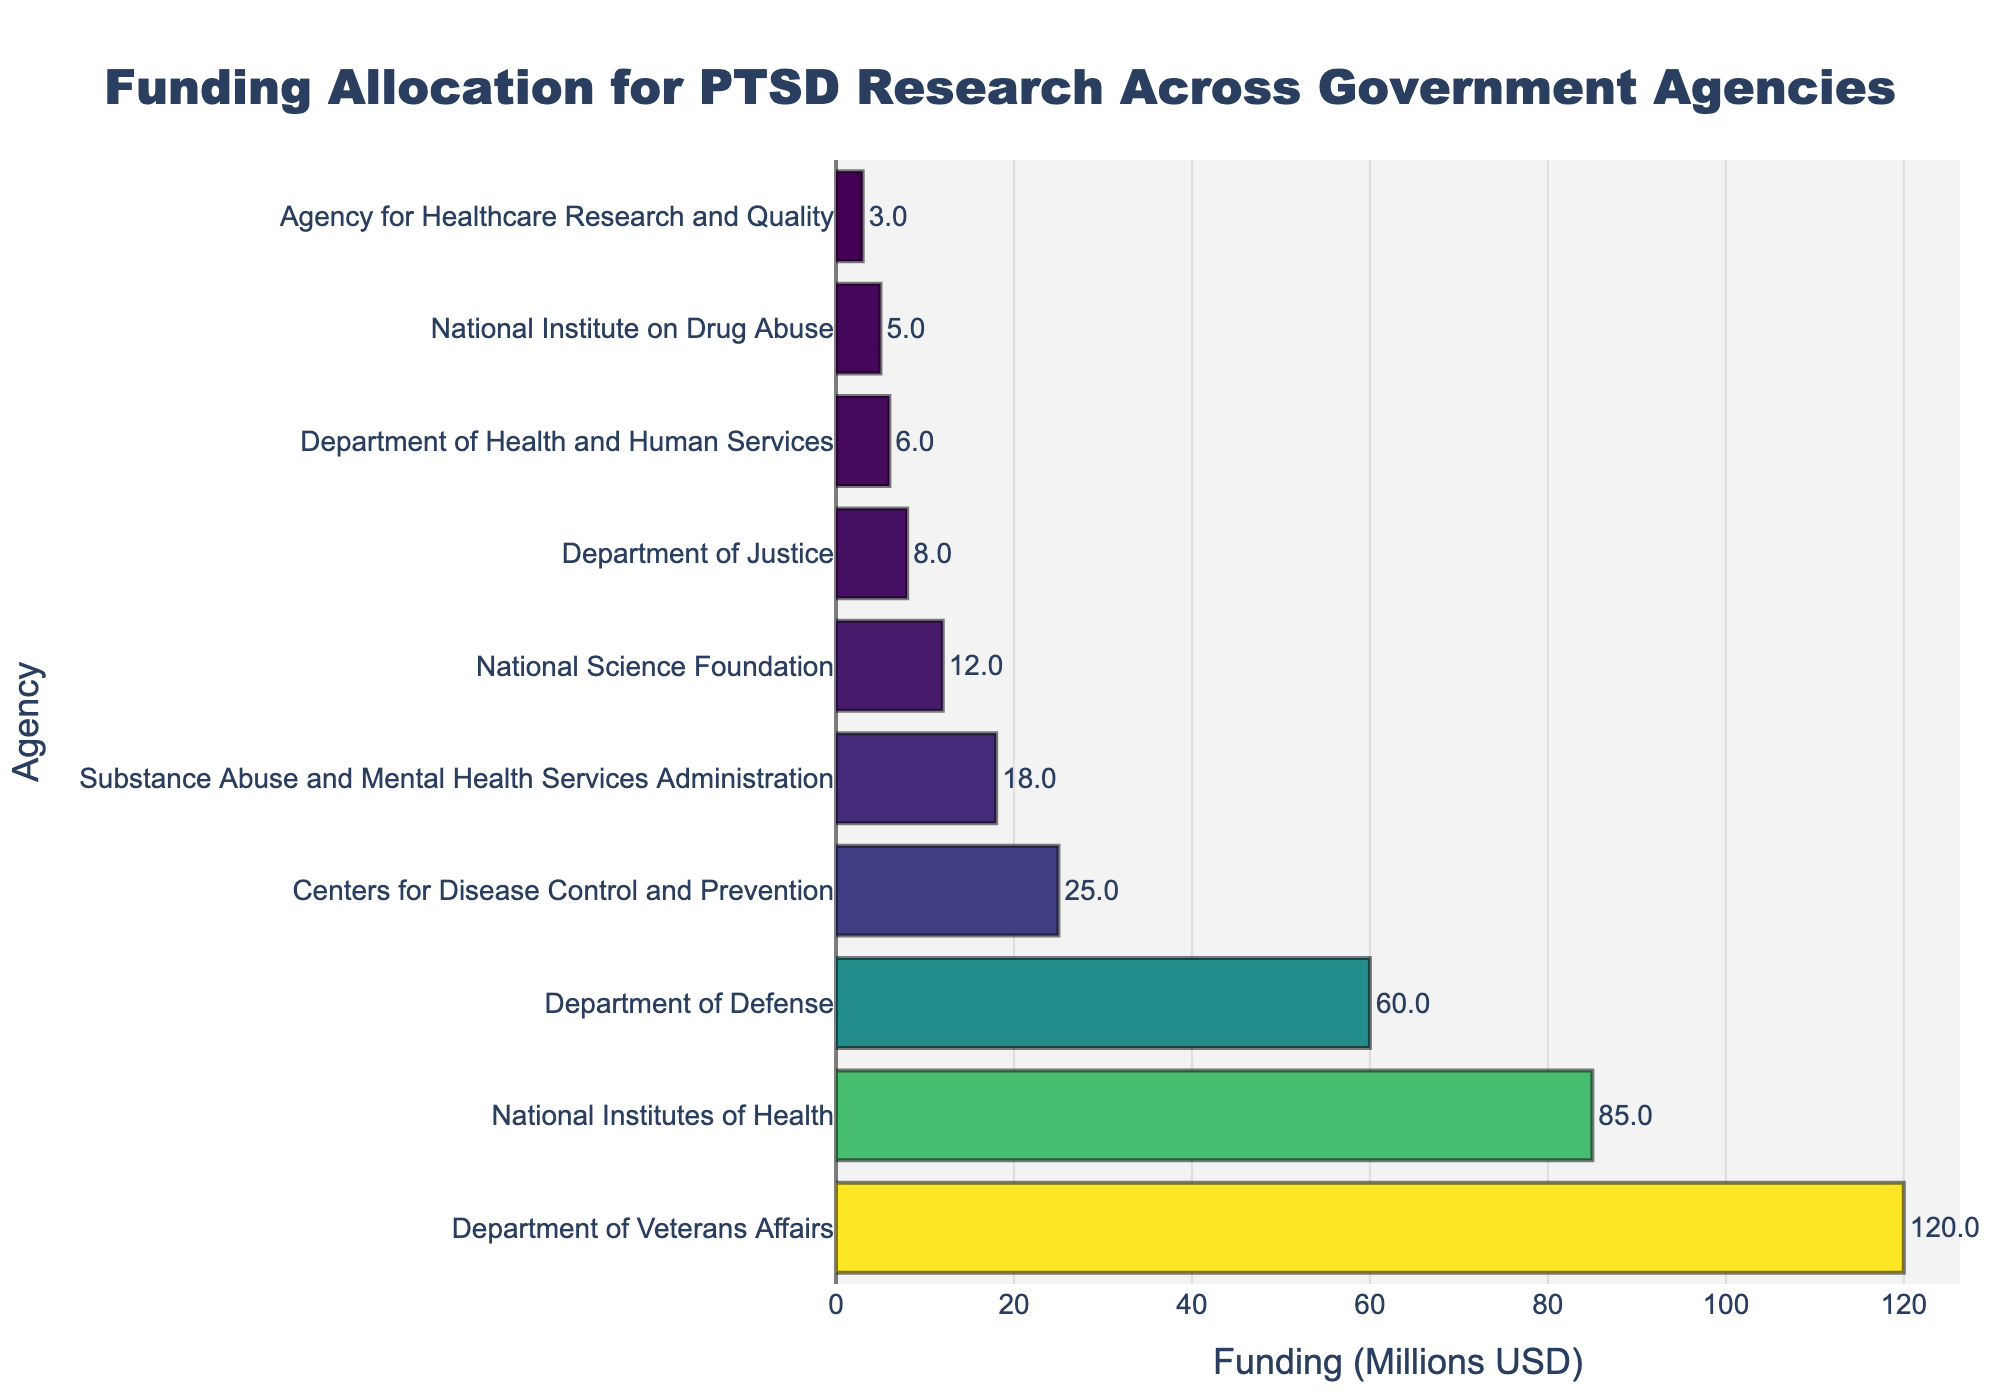How much more funding does the Department of Veterans Affairs receive for PTSD research compared to the Department of Defense? The Department of Veterans Affairs receives 120 million USD, while the Department of Defense receives 60 million USD. The difference is 120 - 60 = 60 million USD.
Answer: 60 million USD What is the total funding allocated for PTSD research by the top three agencies? The top three agencies are the Department of Veterans Affairs (120 million USD), the National Institutes of Health (85 million USD), and the Department of Defense (60 million USD). The total funding is 120 + 85 + 60 = 265 million USD.
Answer: 265 million USD Which agency allocates the least funding for PTSD research? By examining the bar lengths, the Agency for Healthcare Research and Quality allocates the least funding, which is 3 million USD.
Answer: Agency for Healthcare Research and Quality How does the funding allocated by the Centers for Disease Control and Prevention compare to that of the National Science Foundation? The Centers for Disease Control and Prevention allocates 25 million USD, while the National Science Foundation allocates 12 million USD. The CDC’s funding is 25 - 12 = 13 million USD more.
Answer: 13 million USD more What is the combined funding of agencies that allocate less than 20 million USD each for PTSD research? The agencies are the Substance Abuse and Mental Health Services Administration (18 million USD), the National Science Foundation (12 million USD), the Department of Justice (8 million USD), the Department of Health and Human Services (6 million USD), the National Institute on Drug Abuse (5 million USD), and the Agency for Healthcare Research and Quality (3 million USD). The combined funding is 18 + 12 + 8 + 6 + 5 + 3 = 52 million USD.
Answer: 52 million USD By what percentage does the funding of the top agency exceed the average funding of all the agencies? The total funding of all agencies is 120 + 85 + 60 + 25 + 18 + 12 + 8 + 6 + 5 + 3 = 342 million USD. The average funding is 342 / 10 = 34.2 million USD. The top agency (Department of Veterans Affairs) allocates 120 million USD. The percentage increase is ((120 - 34.2) / 34.2) * 100 ≈ 251%.
Answer: 251% How many agencies allocate more than 50 million USD for PTSD research? By looking at the bar lengths, the agencies are the Department of Veterans Affairs (120 million USD), the National Institutes of Health (85 million USD), and the Department of Defense (60 million USD).
Answer: 3 agencies What is the sum of the funding from the agencies that allocate more than 10 million USD but less than 50 million USD for PTSD research? The agencies are the Centers for Disease Control and Prevention (25 million USD), the Substance Abuse and Mental Health Services Administration (18 million USD), and the National Science Foundation (12 million USD). The total is 25 + 18 + 12 = 55 million USD.
Answer: 55 million USD Which agency receives approximately one-fourth of the funding that the Department of Veterans Affairs receives? One-fourth of the Department of Veterans Affairs funding (120 million USD) is 120 / 4 = 30 million USD. The Department of Defense receives 60 million USD, which is closest to one-fourth when approximately halved.
Answer: Department of Defense Considering the visual color gradient, which agency's funding is represented with the lightest color on the chart? Observing the color gradient from dark to light, the Agency for Healthcare Research and Quality (3 million USD) has the lightest color.
Answer: Agency for Healthcare Research and Quality 